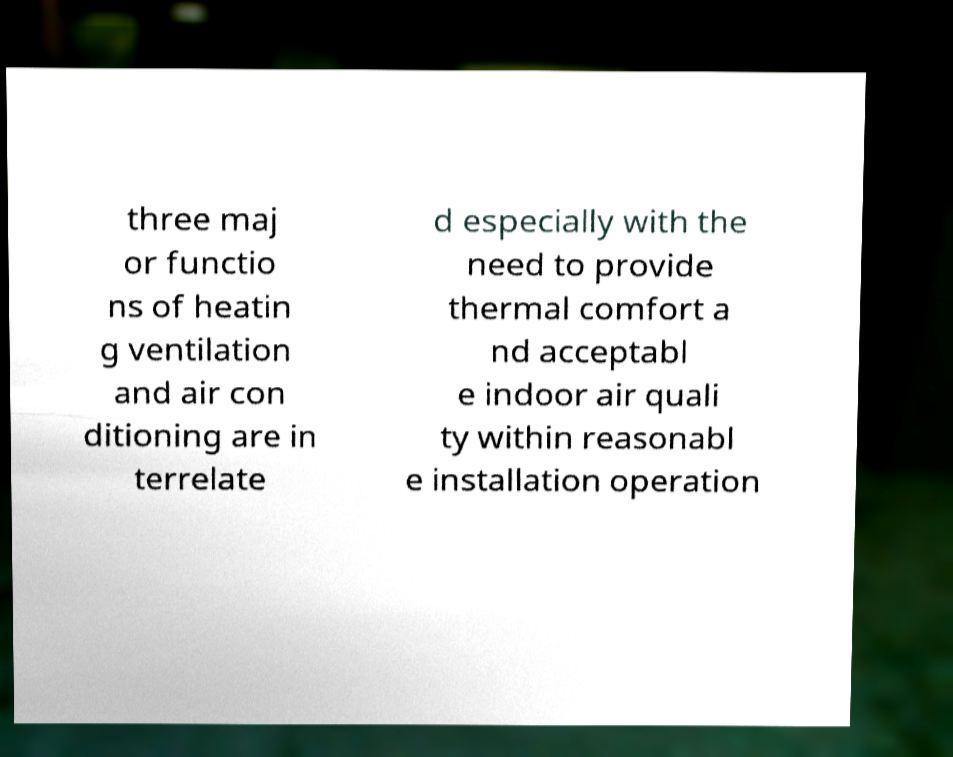Could you extract and type out the text from this image? three maj or functio ns of heatin g ventilation and air con ditioning are in terrelate d especially with the need to provide thermal comfort a nd acceptabl e indoor air quali ty within reasonabl e installation operation 